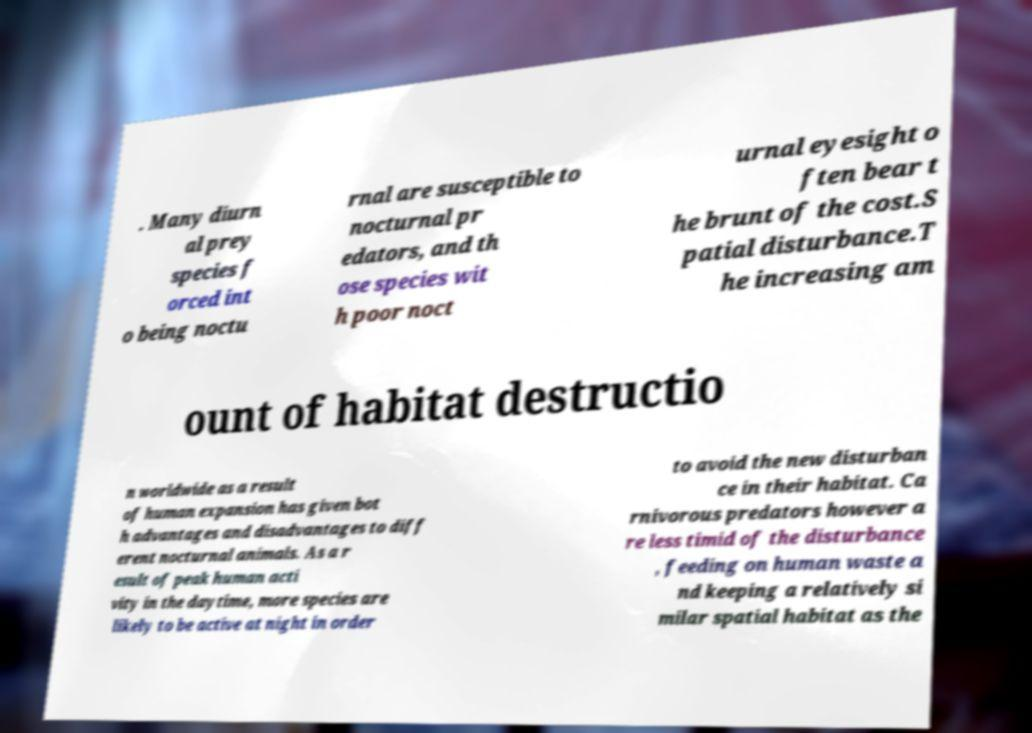What messages or text are displayed in this image? I need them in a readable, typed format. . Many diurn al prey species f orced int o being noctu rnal are susceptible to nocturnal pr edators, and th ose species wit h poor noct urnal eyesight o ften bear t he brunt of the cost.S patial disturbance.T he increasing am ount of habitat destructio n worldwide as a result of human expansion has given bot h advantages and disadvantages to diff erent nocturnal animals. As a r esult of peak human acti vity in the daytime, more species are likely to be active at night in order to avoid the new disturban ce in their habitat. Ca rnivorous predators however a re less timid of the disturbance , feeding on human waste a nd keeping a relatively si milar spatial habitat as the 